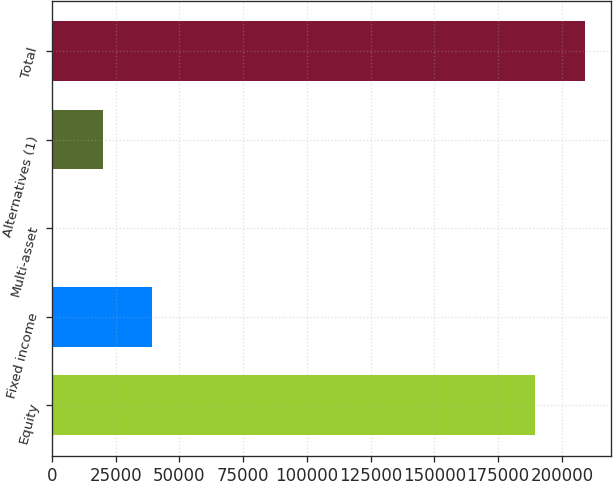Convert chart to OTSL. <chart><loc_0><loc_0><loc_500><loc_500><bar_chart><fcel>Equity<fcel>Fixed income<fcel>Multi-asset<fcel>Alternatives (1)<fcel>Total<nl><fcel>189472<fcel>39369.4<fcel>280<fcel>19824.7<fcel>209017<nl></chart> 